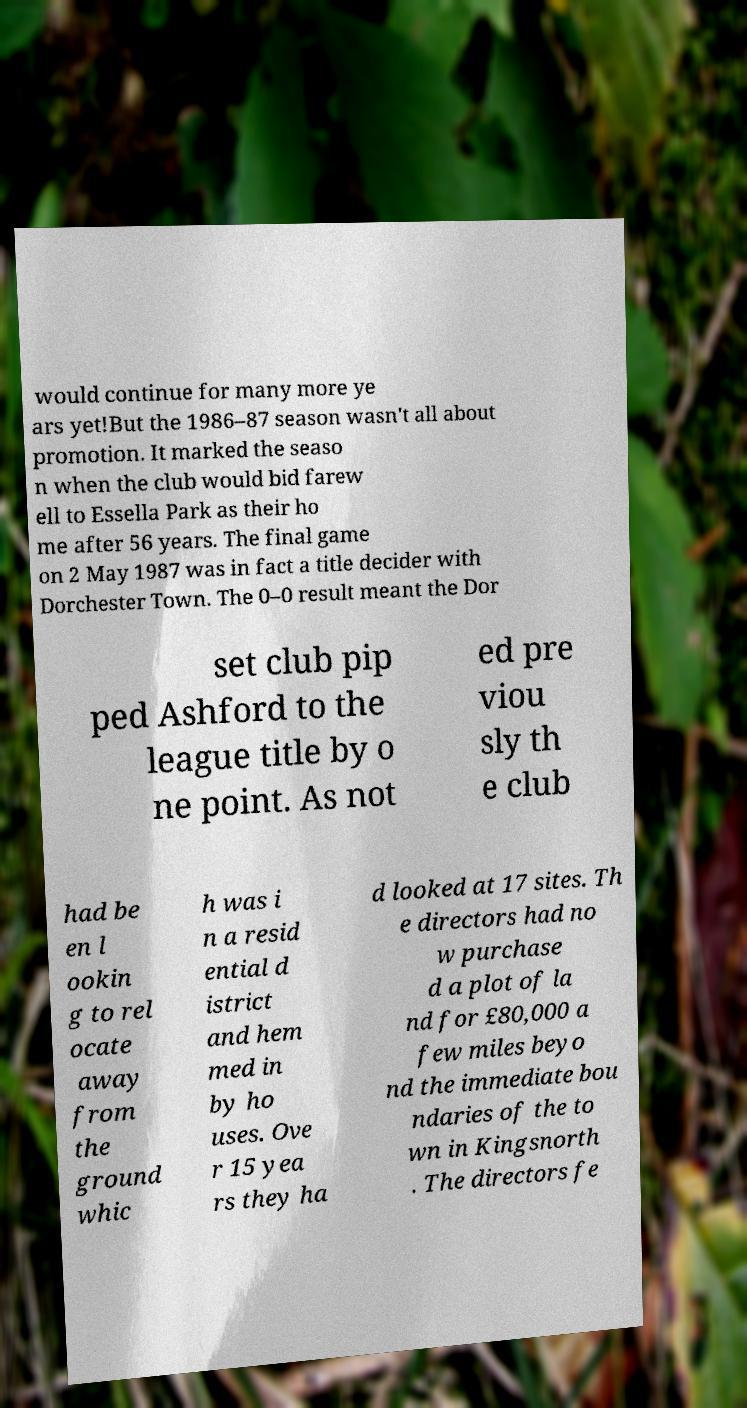Please identify and transcribe the text found in this image. would continue for many more ye ars yet!But the 1986–87 season wasn't all about promotion. It marked the seaso n when the club would bid farew ell to Essella Park as their ho me after 56 years. The final game on 2 May 1987 was in fact a title decider with Dorchester Town. The 0–0 result meant the Dor set club pip ped Ashford to the league title by o ne point. As not ed pre viou sly th e club had be en l ookin g to rel ocate away from the ground whic h was i n a resid ential d istrict and hem med in by ho uses. Ove r 15 yea rs they ha d looked at 17 sites. Th e directors had no w purchase d a plot of la nd for £80,000 a few miles beyo nd the immediate bou ndaries of the to wn in Kingsnorth . The directors fe 